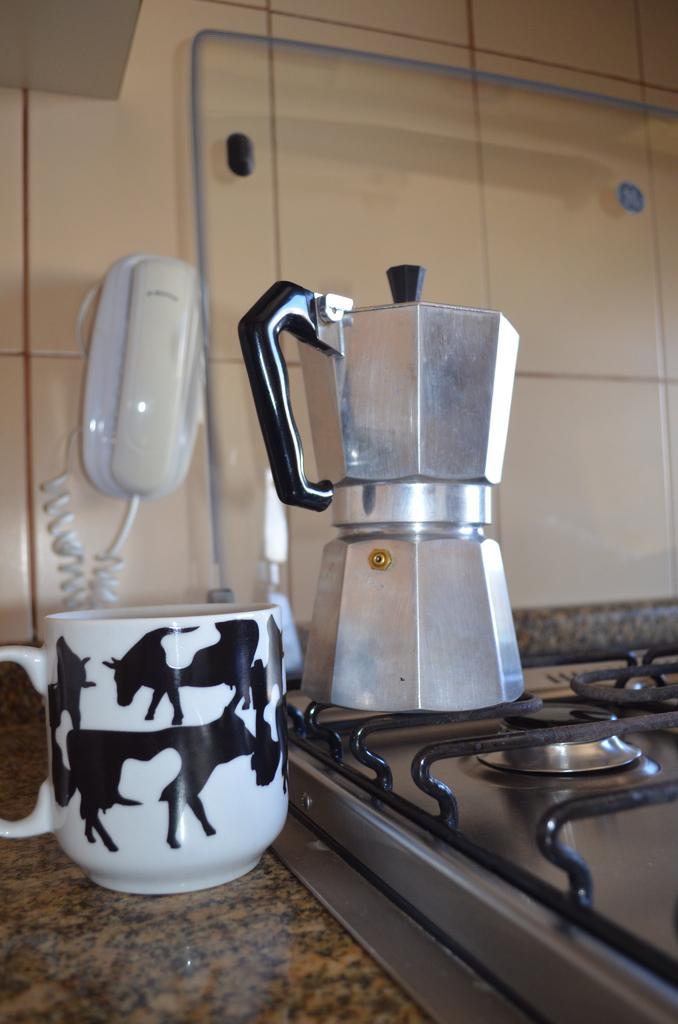In one or two sentences, can you explain what this image depicts? At the bottom of the image there is stove and there is cup and mixer. At the top of the image there is a wall, on the wall there is a landline phone. 